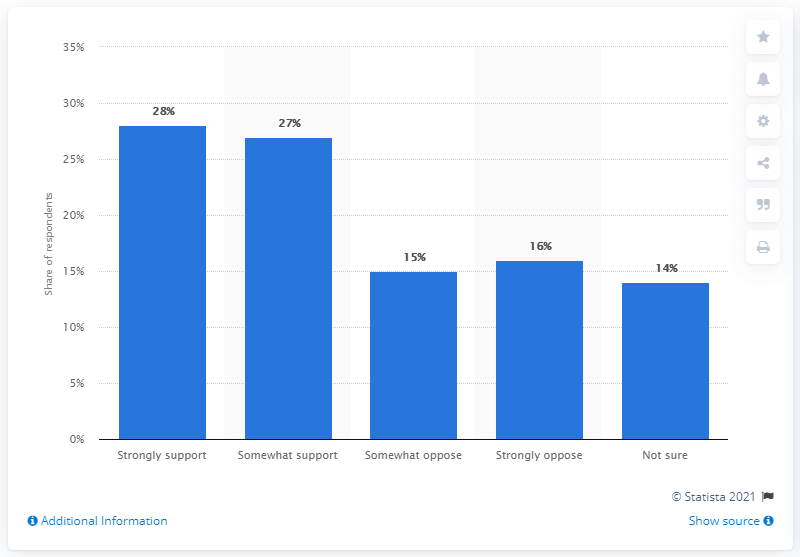Draw attention to some important aspects in this diagram. Supporting and opposing opinions differ in their stance and arguments presented. The median value is 15. 